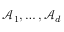<formula> <loc_0><loc_0><loc_500><loc_500>\mathcal { A } _ { 1 } , \dots , \mathcal { A } _ { d }</formula> 